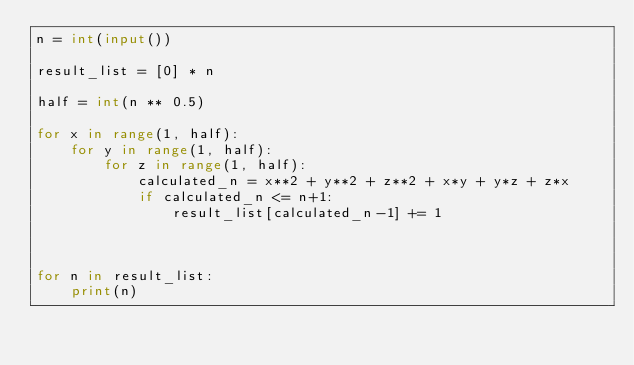<code> <loc_0><loc_0><loc_500><loc_500><_Python_>n = int(input())

result_list = [0] * n

half = int(n ** 0.5)

for x in range(1, half):
    for y in range(1, half):
        for z in range(1, half):
            calculated_n = x**2 + y**2 + z**2 + x*y + y*z + z*x
            if calculated_n <= n+1:
                result_list[calculated_n-1] += 1



for n in result_list:
    print(n)</code> 